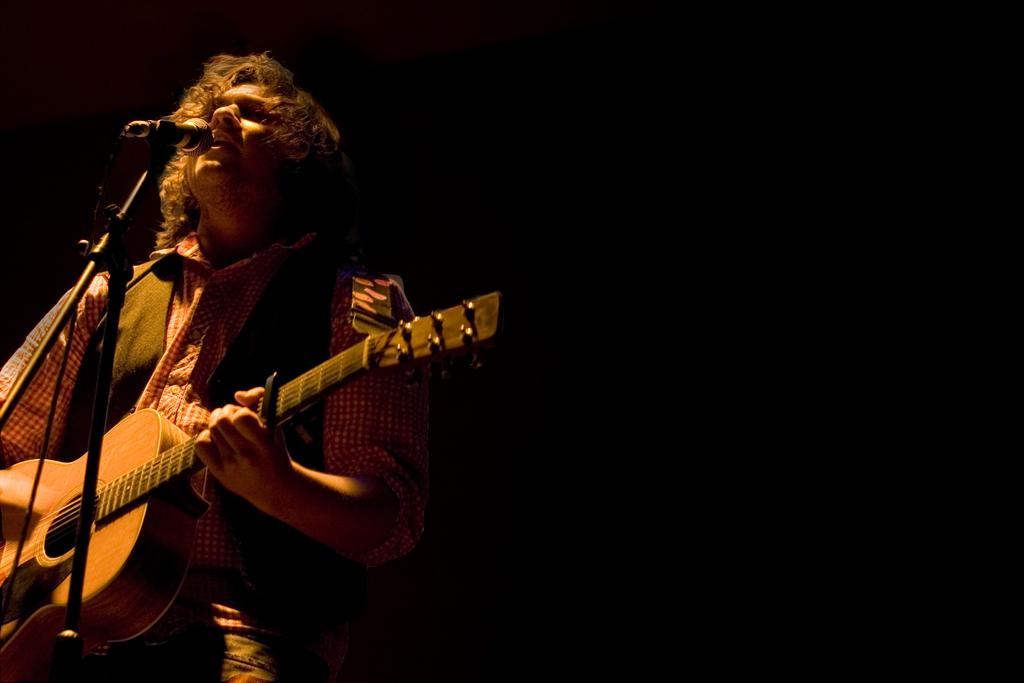What is the man in the image doing? The man is holding a guitar and singing. What object is the man using to amplify his voice? There is a microphone in the image. What type of fuel is the man using to power his guitar in the image? There is no indication in the image that the man's guitar requires fuel, as guitars are typically powered by electricity or played acoustically. 